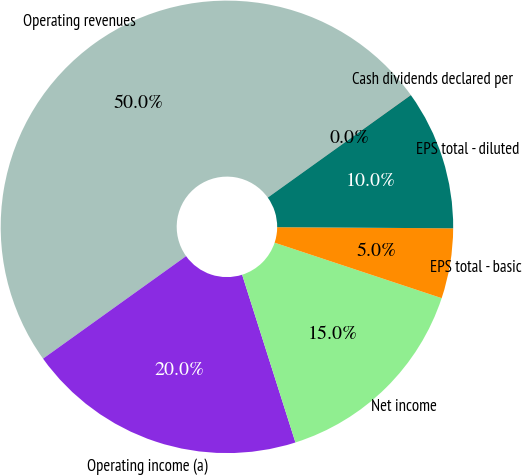<chart> <loc_0><loc_0><loc_500><loc_500><pie_chart><fcel>Operating revenues<fcel>Operating income (a)<fcel>Net income<fcel>EPS total - basic<fcel>EPS total - diluted<fcel>Cash dividends declared per<nl><fcel>49.99%<fcel>20.0%<fcel>15.0%<fcel>5.0%<fcel>10.0%<fcel>0.01%<nl></chart> 